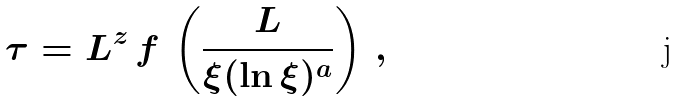<formula> <loc_0><loc_0><loc_500><loc_500>\tau = L ^ { z } \, f \, \left ( \frac { L } { \xi ( \ln { \xi } ) ^ { a } } \right ) \, ,</formula> 